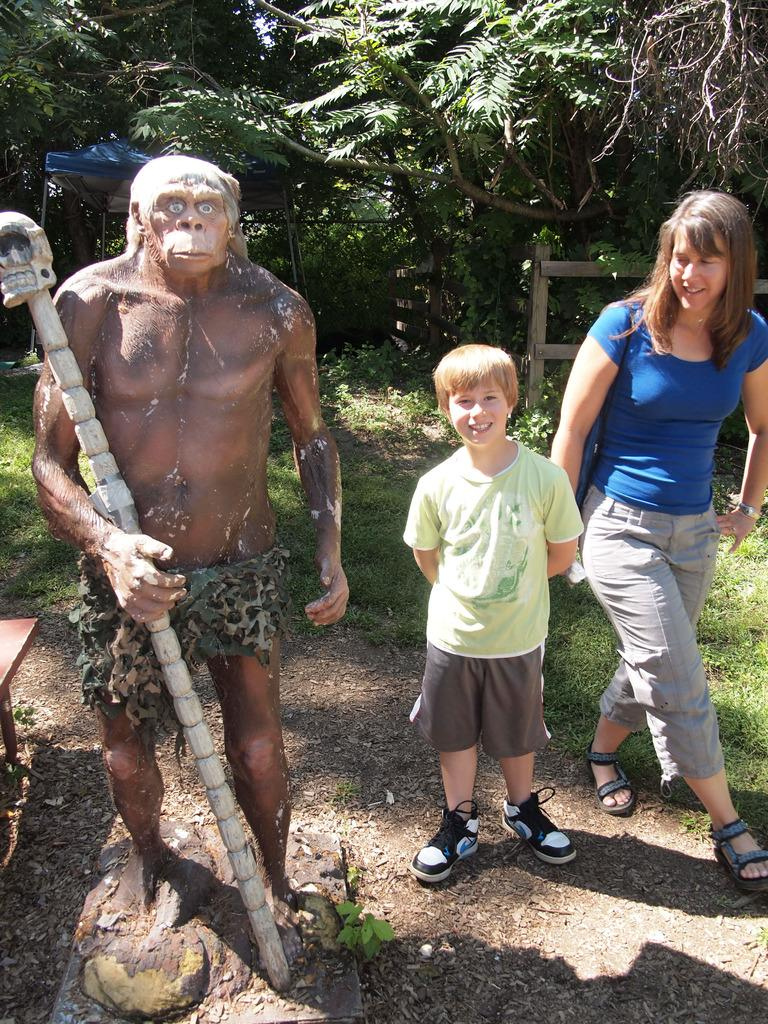Who is present in the image? There is a lady and a boy in the image. What are the expressions on their faces? Both the lady and the boy are smiling. What can be seen on the left side of the image? There is a sculpture on the left side of the image. What is visible in the background of the image? There are trees, a tent, and a fence in the background of the image. What type of animal is sitting on the fence in the image? There is no animal present on the fence in the image. What kind of quartz can be seen in the sculpture on the left side of the image? The image does not provide information about the materials used in the sculpture, so it cannot be determined if quartz is present. 